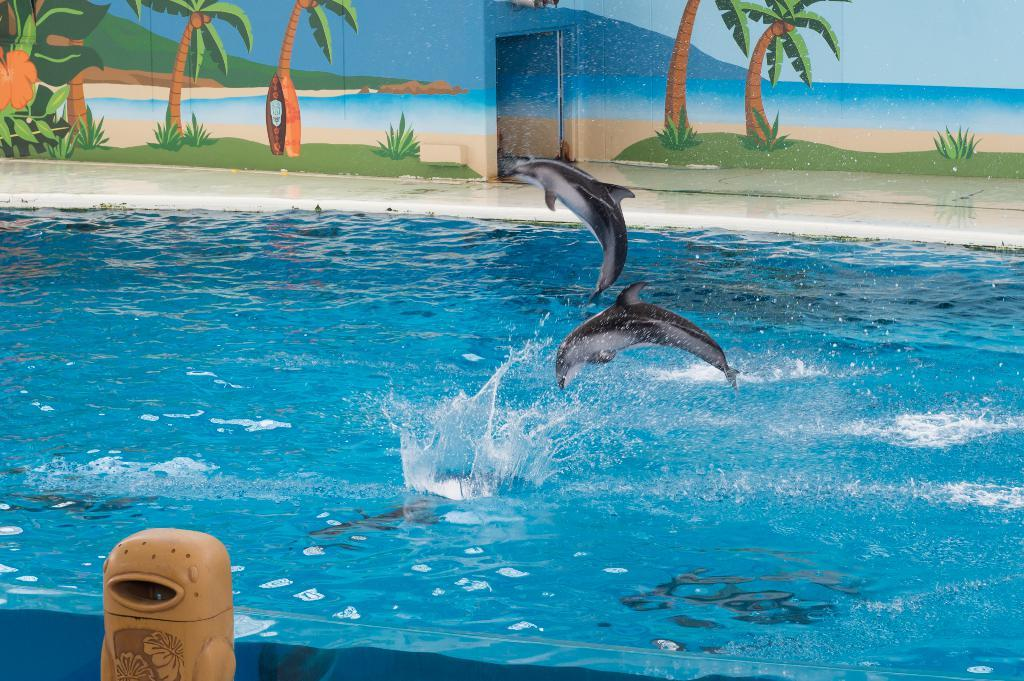What animals are present in the image? There are dolphins in the image. What are the dolphins doing in the image? The dolphins are jumping into the water. Can you describe the object near the water in the image? Unfortunately, the facts provided do not give enough information to describe the object near the water. What can be seen in the background of the image? There is a wall with a painting and a door in the background of the image. How many women are playing the horn in the image? There are no women or horns present in the image; it features dolphins jumping into the water. 